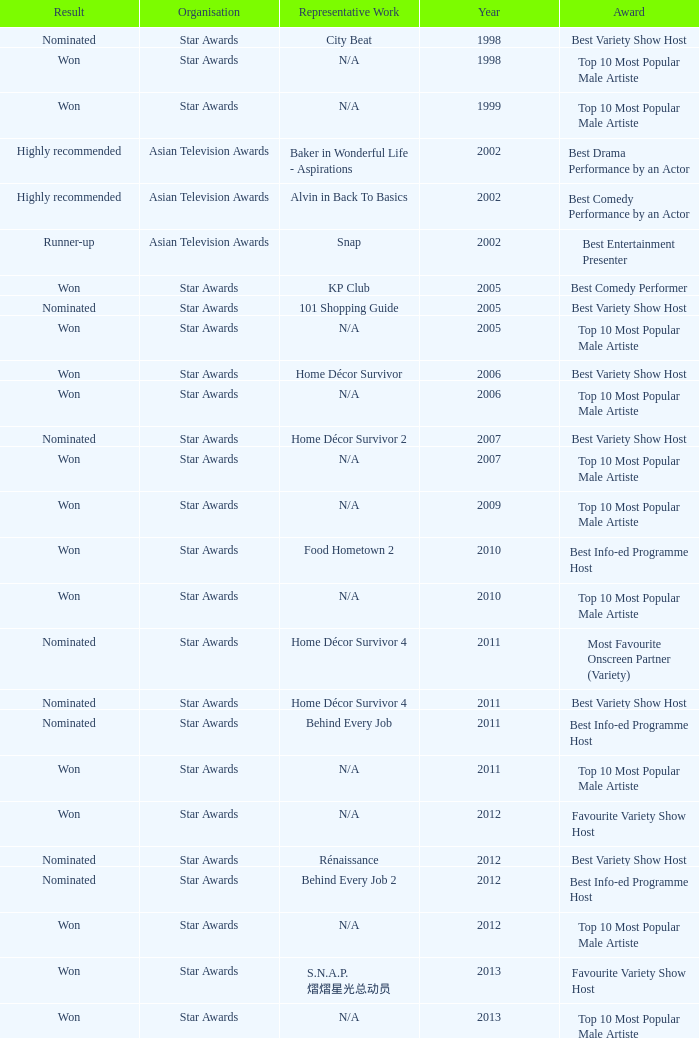What is the name of the award in a year more than 2005, and the Result of nominated? Best Variety Show Host, Most Favourite Onscreen Partner (Variety), Best Variety Show Host, Best Info-ed Programme Host, Best Variety Show Host, Best Info-ed Programme Host, Best Info-Ed Programme Host, Best Variety Show Host. 